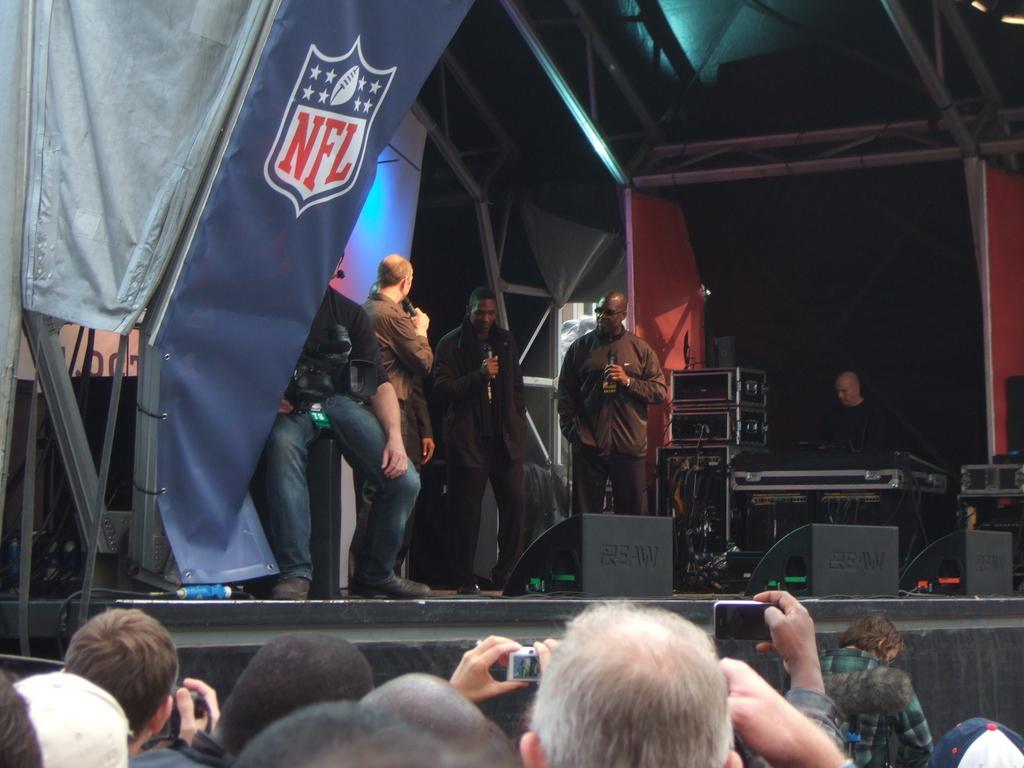Can you describe this image briefly? In this image at the bottom we can see few persons and among them few persons are holding cameras and mobile in their hands. In the background we can see few persons are standing on the stage and holding cameras in their hands and a person is sitting on a platform and holding a camera, banners, poles, boxes, electronic items, cables, lights, screen and a person is on the right side. 